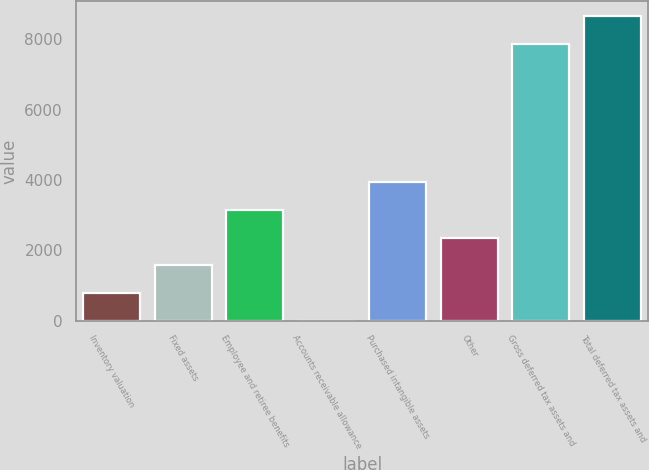Convert chart. <chart><loc_0><loc_0><loc_500><loc_500><bar_chart><fcel>Inventory valuation<fcel>Fixed assets<fcel>Employee and retiree benefits<fcel>Accounts receivable allowance<fcel>Purchased intangible assets<fcel>Other<fcel>Gross deferred tax assets and<fcel>Total deferred tax assets and<nl><fcel>789.4<fcel>1575.8<fcel>3148.6<fcel>3<fcel>3935<fcel>2362.2<fcel>7867<fcel>8653.4<nl></chart> 